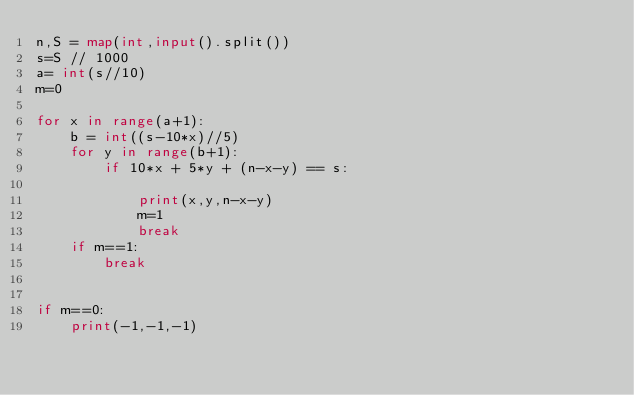<code> <loc_0><loc_0><loc_500><loc_500><_Python_>n,S = map(int,input().split())
s=S // 1000
a= int(s//10)
m=0

for x in range(a+1):
    b = int((s-10*x)//5)
    for y in range(b+1):
        if 10*x + 5*y + (n-x-y) == s:   

            print(x,y,n-x-y)
            m=1
            break
    if m==1:
        break
        

if m==0:
    print(-1,-1,-1)    </code> 